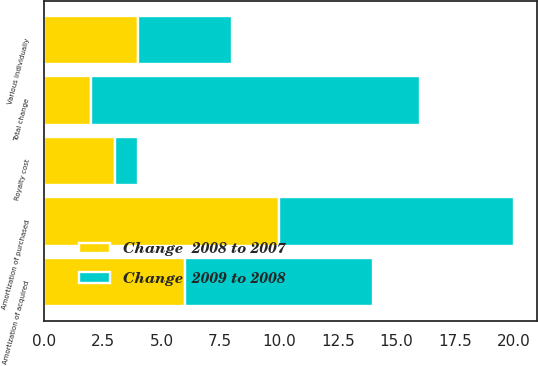Convert chart. <chart><loc_0><loc_0><loc_500><loc_500><stacked_bar_chart><ecel><fcel>Amortization of acquired<fcel>Amortization of purchased<fcel>Royalty cost<fcel>Various individually<fcel>Total change<nl><fcel>Change  2009 to 2008<fcel>8<fcel>10<fcel>1<fcel>4<fcel>14<nl><fcel>Change  2008 to 2007<fcel>6<fcel>10<fcel>3<fcel>4<fcel>2<nl></chart> 